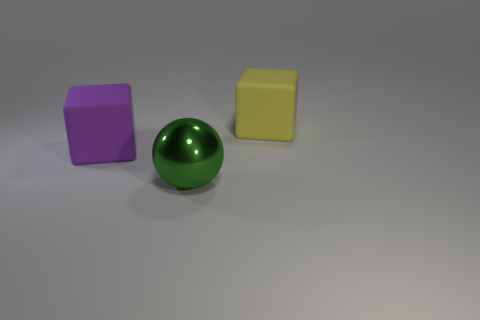Add 2 small gray things. How many objects exist? 5 Subtract all cubes. How many objects are left? 1 Add 1 large green metallic spheres. How many large green metallic spheres are left? 2 Add 1 purple things. How many purple things exist? 2 Subtract 0 yellow cylinders. How many objects are left? 3 Subtract all large purple cubes. Subtract all big yellow rubber things. How many objects are left? 1 